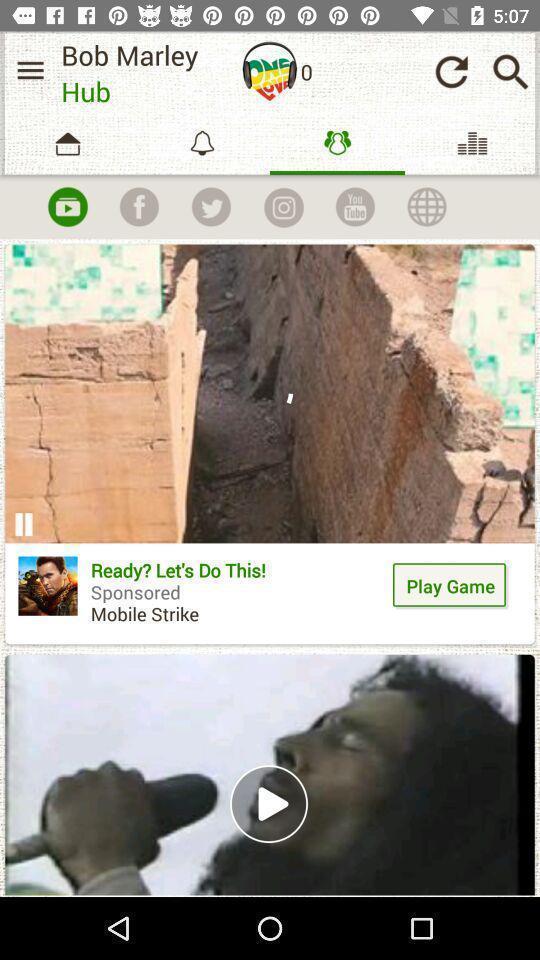Tell me what you see in this picture. Screen shows songs player in a music app. 